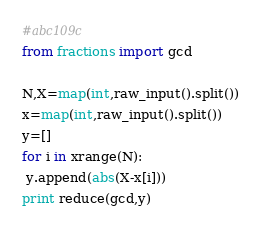Convert code to text. <code><loc_0><loc_0><loc_500><loc_500><_Python_>#abc109c
from fractions import gcd

N,X=map(int,raw_input().split())
x=map(int,raw_input().split())
y=[]
for i in xrange(N):
 y.append(abs(X-x[i]))
print reduce(gcd,y)
</code> 